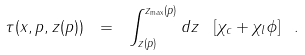<formula> <loc_0><loc_0><loc_500><loc_500>\tau ( x , p , z ( p ) ) \ = \ \int _ { z ( p ) } ^ { z _ { \mathrm \max } ( p ) } d z \ \left [ \chi _ { c } + \chi _ { l } \phi \right ] \ .</formula> 